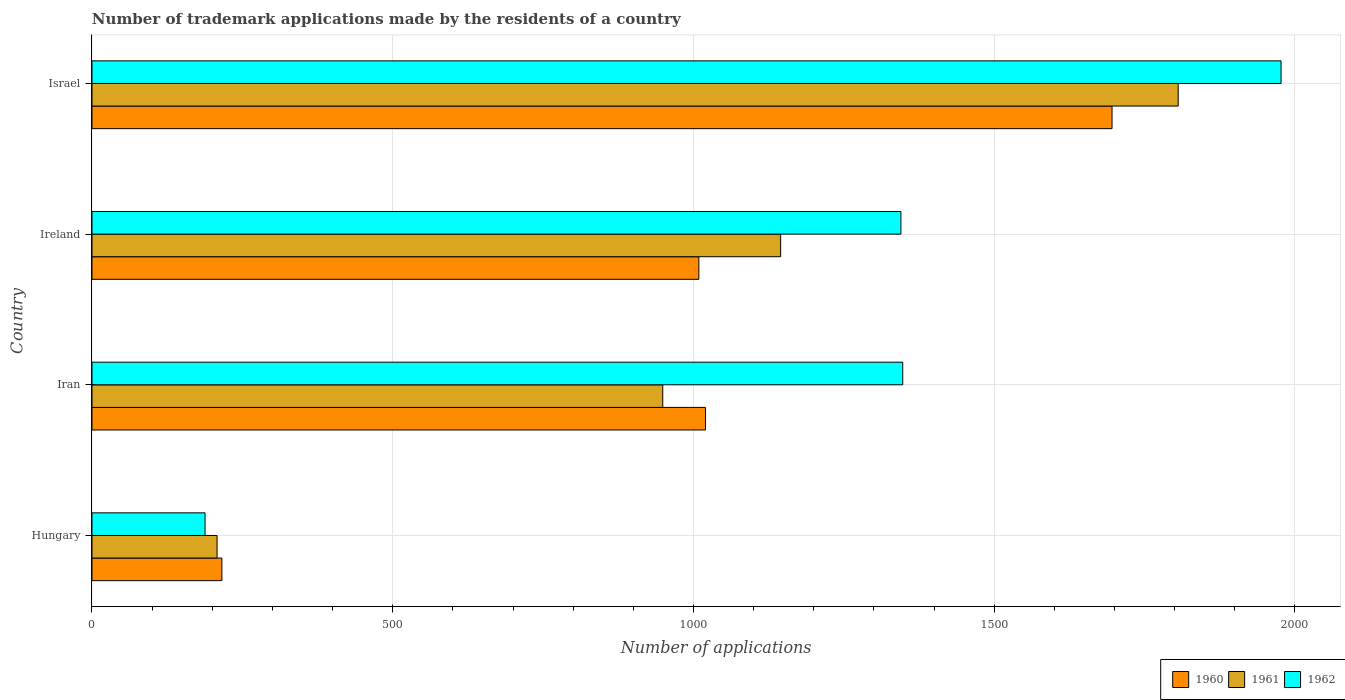How many groups of bars are there?
Offer a terse response. 4. How many bars are there on the 1st tick from the top?
Your answer should be compact. 3. What is the label of the 4th group of bars from the top?
Give a very brief answer. Hungary. In how many cases, is the number of bars for a given country not equal to the number of legend labels?
Your answer should be compact. 0. What is the number of trademark applications made by the residents in 1962 in Hungary?
Make the answer very short. 188. Across all countries, what is the maximum number of trademark applications made by the residents in 1962?
Provide a short and direct response. 1977. Across all countries, what is the minimum number of trademark applications made by the residents in 1962?
Make the answer very short. 188. In which country was the number of trademark applications made by the residents in 1961 maximum?
Your answer should be compact. Israel. In which country was the number of trademark applications made by the residents in 1961 minimum?
Your response must be concise. Hungary. What is the total number of trademark applications made by the residents in 1961 in the graph?
Make the answer very short. 4108. What is the difference between the number of trademark applications made by the residents in 1962 in Ireland and the number of trademark applications made by the residents in 1960 in Iran?
Make the answer very short. 325. What is the average number of trademark applications made by the residents in 1962 per country?
Keep it short and to the point. 1214.5. What is the difference between the number of trademark applications made by the residents in 1962 and number of trademark applications made by the residents in 1961 in Hungary?
Your answer should be very brief. -20. What is the ratio of the number of trademark applications made by the residents in 1960 in Hungary to that in Israel?
Keep it short and to the point. 0.13. What is the difference between the highest and the second highest number of trademark applications made by the residents in 1962?
Make the answer very short. 629. What is the difference between the highest and the lowest number of trademark applications made by the residents in 1962?
Your answer should be very brief. 1789. Is it the case that in every country, the sum of the number of trademark applications made by the residents in 1960 and number of trademark applications made by the residents in 1962 is greater than the number of trademark applications made by the residents in 1961?
Provide a succinct answer. Yes. Are all the bars in the graph horizontal?
Your answer should be compact. Yes. Does the graph contain any zero values?
Provide a short and direct response. No. Does the graph contain grids?
Your answer should be compact. Yes. Where does the legend appear in the graph?
Your response must be concise. Bottom right. How many legend labels are there?
Offer a very short reply. 3. How are the legend labels stacked?
Your response must be concise. Horizontal. What is the title of the graph?
Ensure brevity in your answer.  Number of trademark applications made by the residents of a country. What is the label or title of the X-axis?
Your answer should be compact. Number of applications. What is the label or title of the Y-axis?
Your response must be concise. Country. What is the Number of applications of 1960 in Hungary?
Keep it short and to the point. 216. What is the Number of applications in 1961 in Hungary?
Make the answer very short. 208. What is the Number of applications in 1962 in Hungary?
Offer a terse response. 188. What is the Number of applications in 1960 in Iran?
Your response must be concise. 1020. What is the Number of applications of 1961 in Iran?
Offer a terse response. 949. What is the Number of applications of 1962 in Iran?
Your answer should be compact. 1348. What is the Number of applications of 1960 in Ireland?
Your answer should be compact. 1009. What is the Number of applications of 1961 in Ireland?
Ensure brevity in your answer.  1145. What is the Number of applications in 1962 in Ireland?
Keep it short and to the point. 1345. What is the Number of applications in 1960 in Israel?
Keep it short and to the point. 1696. What is the Number of applications in 1961 in Israel?
Keep it short and to the point. 1806. What is the Number of applications in 1962 in Israel?
Make the answer very short. 1977. Across all countries, what is the maximum Number of applications of 1960?
Keep it short and to the point. 1696. Across all countries, what is the maximum Number of applications of 1961?
Your answer should be very brief. 1806. Across all countries, what is the maximum Number of applications in 1962?
Your answer should be very brief. 1977. Across all countries, what is the minimum Number of applications in 1960?
Provide a succinct answer. 216. Across all countries, what is the minimum Number of applications in 1961?
Ensure brevity in your answer.  208. Across all countries, what is the minimum Number of applications in 1962?
Make the answer very short. 188. What is the total Number of applications of 1960 in the graph?
Keep it short and to the point. 3941. What is the total Number of applications in 1961 in the graph?
Offer a terse response. 4108. What is the total Number of applications in 1962 in the graph?
Keep it short and to the point. 4858. What is the difference between the Number of applications in 1960 in Hungary and that in Iran?
Make the answer very short. -804. What is the difference between the Number of applications in 1961 in Hungary and that in Iran?
Your response must be concise. -741. What is the difference between the Number of applications in 1962 in Hungary and that in Iran?
Your answer should be very brief. -1160. What is the difference between the Number of applications in 1960 in Hungary and that in Ireland?
Offer a very short reply. -793. What is the difference between the Number of applications in 1961 in Hungary and that in Ireland?
Provide a succinct answer. -937. What is the difference between the Number of applications of 1962 in Hungary and that in Ireland?
Your answer should be very brief. -1157. What is the difference between the Number of applications of 1960 in Hungary and that in Israel?
Your response must be concise. -1480. What is the difference between the Number of applications of 1961 in Hungary and that in Israel?
Your response must be concise. -1598. What is the difference between the Number of applications of 1962 in Hungary and that in Israel?
Make the answer very short. -1789. What is the difference between the Number of applications of 1960 in Iran and that in Ireland?
Provide a succinct answer. 11. What is the difference between the Number of applications of 1961 in Iran and that in Ireland?
Provide a succinct answer. -196. What is the difference between the Number of applications in 1962 in Iran and that in Ireland?
Your answer should be compact. 3. What is the difference between the Number of applications in 1960 in Iran and that in Israel?
Offer a very short reply. -676. What is the difference between the Number of applications of 1961 in Iran and that in Israel?
Your answer should be compact. -857. What is the difference between the Number of applications in 1962 in Iran and that in Israel?
Offer a very short reply. -629. What is the difference between the Number of applications in 1960 in Ireland and that in Israel?
Provide a succinct answer. -687. What is the difference between the Number of applications of 1961 in Ireland and that in Israel?
Make the answer very short. -661. What is the difference between the Number of applications of 1962 in Ireland and that in Israel?
Your answer should be very brief. -632. What is the difference between the Number of applications in 1960 in Hungary and the Number of applications in 1961 in Iran?
Make the answer very short. -733. What is the difference between the Number of applications of 1960 in Hungary and the Number of applications of 1962 in Iran?
Offer a terse response. -1132. What is the difference between the Number of applications in 1961 in Hungary and the Number of applications in 1962 in Iran?
Your answer should be compact. -1140. What is the difference between the Number of applications of 1960 in Hungary and the Number of applications of 1961 in Ireland?
Offer a terse response. -929. What is the difference between the Number of applications of 1960 in Hungary and the Number of applications of 1962 in Ireland?
Offer a terse response. -1129. What is the difference between the Number of applications of 1961 in Hungary and the Number of applications of 1962 in Ireland?
Offer a very short reply. -1137. What is the difference between the Number of applications in 1960 in Hungary and the Number of applications in 1961 in Israel?
Make the answer very short. -1590. What is the difference between the Number of applications of 1960 in Hungary and the Number of applications of 1962 in Israel?
Offer a very short reply. -1761. What is the difference between the Number of applications in 1961 in Hungary and the Number of applications in 1962 in Israel?
Your response must be concise. -1769. What is the difference between the Number of applications of 1960 in Iran and the Number of applications of 1961 in Ireland?
Make the answer very short. -125. What is the difference between the Number of applications in 1960 in Iran and the Number of applications in 1962 in Ireland?
Provide a short and direct response. -325. What is the difference between the Number of applications of 1961 in Iran and the Number of applications of 1962 in Ireland?
Your answer should be very brief. -396. What is the difference between the Number of applications of 1960 in Iran and the Number of applications of 1961 in Israel?
Give a very brief answer. -786. What is the difference between the Number of applications of 1960 in Iran and the Number of applications of 1962 in Israel?
Provide a short and direct response. -957. What is the difference between the Number of applications in 1961 in Iran and the Number of applications in 1962 in Israel?
Your answer should be very brief. -1028. What is the difference between the Number of applications of 1960 in Ireland and the Number of applications of 1961 in Israel?
Provide a short and direct response. -797. What is the difference between the Number of applications in 1960 in Ireland and the Number of applications in 1962 in Israel?
Keep it short and to the point. -968. What is the difference between the Number of applications in 1961 in Ireland and the Number of applications in 1962 in Israel?
Offer a terse response. -832. What is the average Number of applications of 1960 per country?
Give a very brief answer. 985.25. What is the average Number of applications in 1961 per country?
Your response must be concise. 1027. What is the average Number of applications of 1962 per country?
Your answer should be very brief. 1214.5. What is the difference between the Number of applications in 1960 and Number of applications in 1961 in Hungary?
Your answer should be compact. 8. What is the difference between the Number of applications of 1960 and Number of applications of 1962 in Hungary?
Your response must be concise. 28. What is the difference between the Number of applications in 1961 and Number of applications in 1962 in Hungary?
Offer a terse response. 20. What is the difference between the Number of applications of 1960 and Number of applications of 1962 in Iran?
Provide a succinct answer. -328. What is the difference between the Number of applications in 1961 and Number of applications in 1962 in Iran?
Offer a terse response. -399. What is the difference between the Number of applications in 1960 and Number of applications in 1961 in Ireland?
Offer a terse response. -136. What is the difference between the Number of applications in 1960 and Number of applications in 1962 in Ireland?
Offer a very short reply. -336. What is the difference between the Number of applications in 1961 and Number of applications in 1962 in Ireland?
Your response must be concise. -200. What is the difference between the Number of applications of 1960 and Number of applications of 1961 in Israel?
Your answer should be very brief. -110. What is the difference between the Number of applications of 1960 and Number of applications of 1962 in Israel?
Provide a succinct answer. -281. What is the difference between the Number of applications in 1961 and Number of applications in 1962 in Israel?
Your response must be concise. -171. What is the ratio of the Number of applications of 1960 in Hungary to that in Iran?
Your answer should be very brief. 0.21. What is the ratio of the Number of applications of 1961 in Hungary to that in Iran?
Your response must be concise. 0.22. What is the ratio of the Number of applications in 1962 in Hungary to that in Iran?
Make the answer very short. 0.14. What is the ratio of the Number of applications of 1960 in Hungary to that in Ireland?
Offer a terse response. 0.21. What is the ratio of the Number of applications in 1961 in Hungary to that in Ireland?
Offer a very short reply. 0.18. What is the ratio of the Number of applications of 1962 in Hungary to that in Ireland?
Provide a short and direct response. 0.14. What is the ratio of the Number of applications in 1960 in Hungary to that in Israel?
Offer a terse response. 0.13. What is the ratio of the Number of applications of 1961 in Hungary to that in Israel?
Give a very brief answer. 0.12. What is the ratio of the Number of applications in 1962 in Hungary to that in Israel?
Your answer should be very brief. 0.1. What is the ratio of the Number of applications in 1960 in Iran to that in Ireland?
Make the answer very short. 1.01. What is the ratio of the Number of applications of 1961 in Iran to that in Ireland?
Your answer should be compact. 0.83. What is the ratio of the Number of applications in 1962 in Iran to that in Ireland?
Your response must be concise. 1. What is the ratio of the Number of applications in 1960 in Iran to that in Israel?
Offer a terse response. 0.6. What is the ratio of the Number of applications in 1961 in Iran to that in Israel?
Offer a terse response. 0.53. What is the ratio of the Number of applications in 1962 in Iran to that in Israel?
Keep it short and to the point. 0.68. What is the ratio of the Number of applications in 1960 in Ireland to that in Israel?
Give a very brief answer. 0.59. What is the ratio of the Number of applications of 1961 in Ireland to that in Israel?
Your response must be concise. 0.63. What is the ratio of the Number of applications in 1962 in Ireland to that in Israel?
Offer a terse response. 0.68. What is the difference between the highest and the second highest Number of applications in 1960?
Ensure brevity in your answer.  676. What is the difference between the highest and the second highest Number of applications in 1961?
Ensure brevity in your answer.  661. What is the difference between the highest and the second highest Number of applications of 1962?
Keep it short and to the point. 629. What is the difference between the highest and the lowest Number of applications in 1960?
Your answer should be compact. 1480. What is the difference between the highest and the lowest Number of applications of 1961?
Keep it short and to the point. 1598. What is the difference between the highest and the lowest Number of applications in 1962?
Give a very brief answer. 1789. 